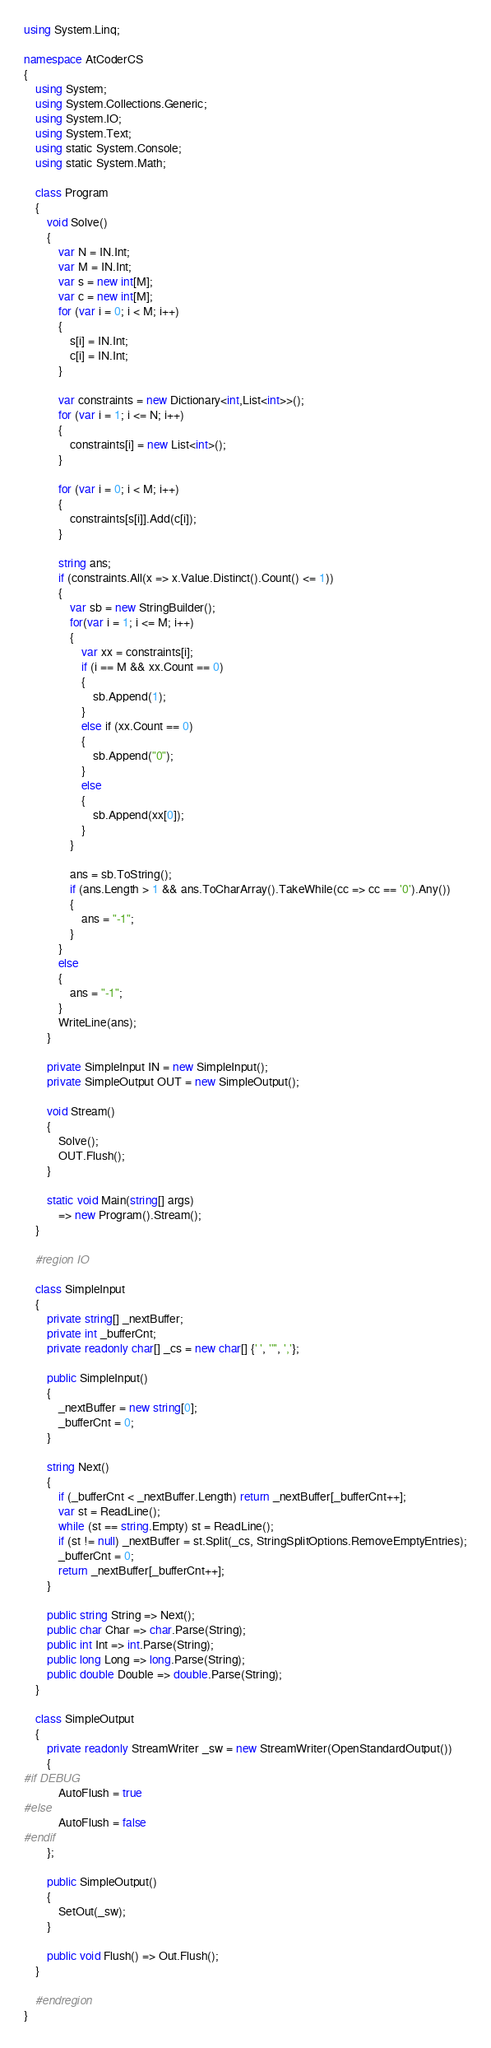Convert code to text. <code><loc_0><loc_0><loc_500><loc_500><_C#_>using System.Linq;

namespace AtCoderCS
{
    using System;
    using System.Collections.Generic;
    using System.IO;
    using System.Text;
    using static System.Console;
    using static System.Math;

    class Program
    {
        void Solve()
        {
            var N = IN.Int;
            var M = IN.Int;
            var s = new int[M];
            var c = new int[M];
            for (var i = 0; i < M; i++)
            {
                s[i] = IN.Int;
                c[i] = IN.Int;
            }

            var constraints = new Dictionary<int,List<int>>();
            for (var i = 1; i <= N; i++)
            {
                constraints[i] = new List<int>();
            }

            for (var i = 0; i < M; i++)
            {
                constraints[s[i]].Add(c[i]);
            }

            string ans;
            if (constraints.All(x => x.Value.Distinct().Count() <= 1))
            {
                var sb = new StringBuilder();
                for(var i = 1; i <= M; i++)
                {
                    var xx = constraints[i];
                    if (i == M && xx.Count == 0)
                    {
                        sb.Append(1);
                    }
                    else if (xx.Count == 0)
                    {
                        sb.Append("0");
                    }
                    else
                    {
                        sb.Append(xx[0]);
                    }
                }

                ans = sb.ToString();
                if (ans.Length > 1 && ans.ToCharArray().TakeWhile(cc => cc == '0').Any())
                {
                    ans = "-1";
                }
            }
            else
            {
                ans = "-1";
            }
            WriteLine(ans);
        }

        private SimpleInput IN = new SimpleInput();
        private SimpleOutput OUT = new SimpleOutput();

        void Stream()
        {
            Solve();
            OUT.Flush();
        }

        static void Main(string[] args)
            => new Program().Stream();
    }

    #region IO

    class SimpleInput
    {
        private string[] _nextBuffer;
        private int _bufferCnt;
        private readonly char[] _cs = new char[] {' ', '"', ','};

        public SimpleInput()
        {
            _nextBuffer = new string[0];
            _bufferCnt = 0;
        }

        string Next()
        {
            if (_bufferCnt < _nextBuffer.Length) return _nextBuffer[_bufferCnt++];
            var st = ReadLine();
            while (st == string.Empty) st = ReadLine();
            if (st != null) _nextBuffer = st.Split(_cs, StringSplitOptions.RemoveEmptyEntries);
            _bufferCnt = 0;
            return _nextBuffer[_bufferCnt++];
        }

        public string String => Next();
        public char Char => char.Parse(String);
        public int Int => int.Parse(String);
        public long Long => long.Parse(String);
        public double Double => double.Parse(String);
    }

    class SimpleOutput
    {
        private readonly StreamWriter _sw = new StreamWriter(OpenStandardOutput())
        {
#if DEBUG
            AutoFlush = true
#else
            AutoFlush = false
#endif
        };

        public SimpleOutput()
        {
            SetOut(_sw);
        }

        public void Flush() => Out.Flush();
    }

    #endregion
}</code> 